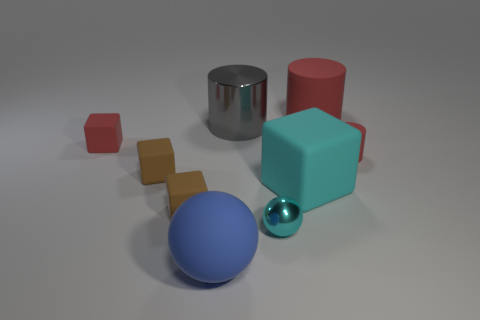What can you tell me about the lighting and shadows in this scene? The lighting in the scene appears to be soft and diffuse, suggesting an overcast sky or a softbox light source used in photography. There's a general illumination that doesn't cause very harsh shadows, providing a gentle contrast to bring out the details of the objects. The shadows which are present are soft-edged and fall mostly to the right of the objects, indicating a light source from the left side of the frame. 